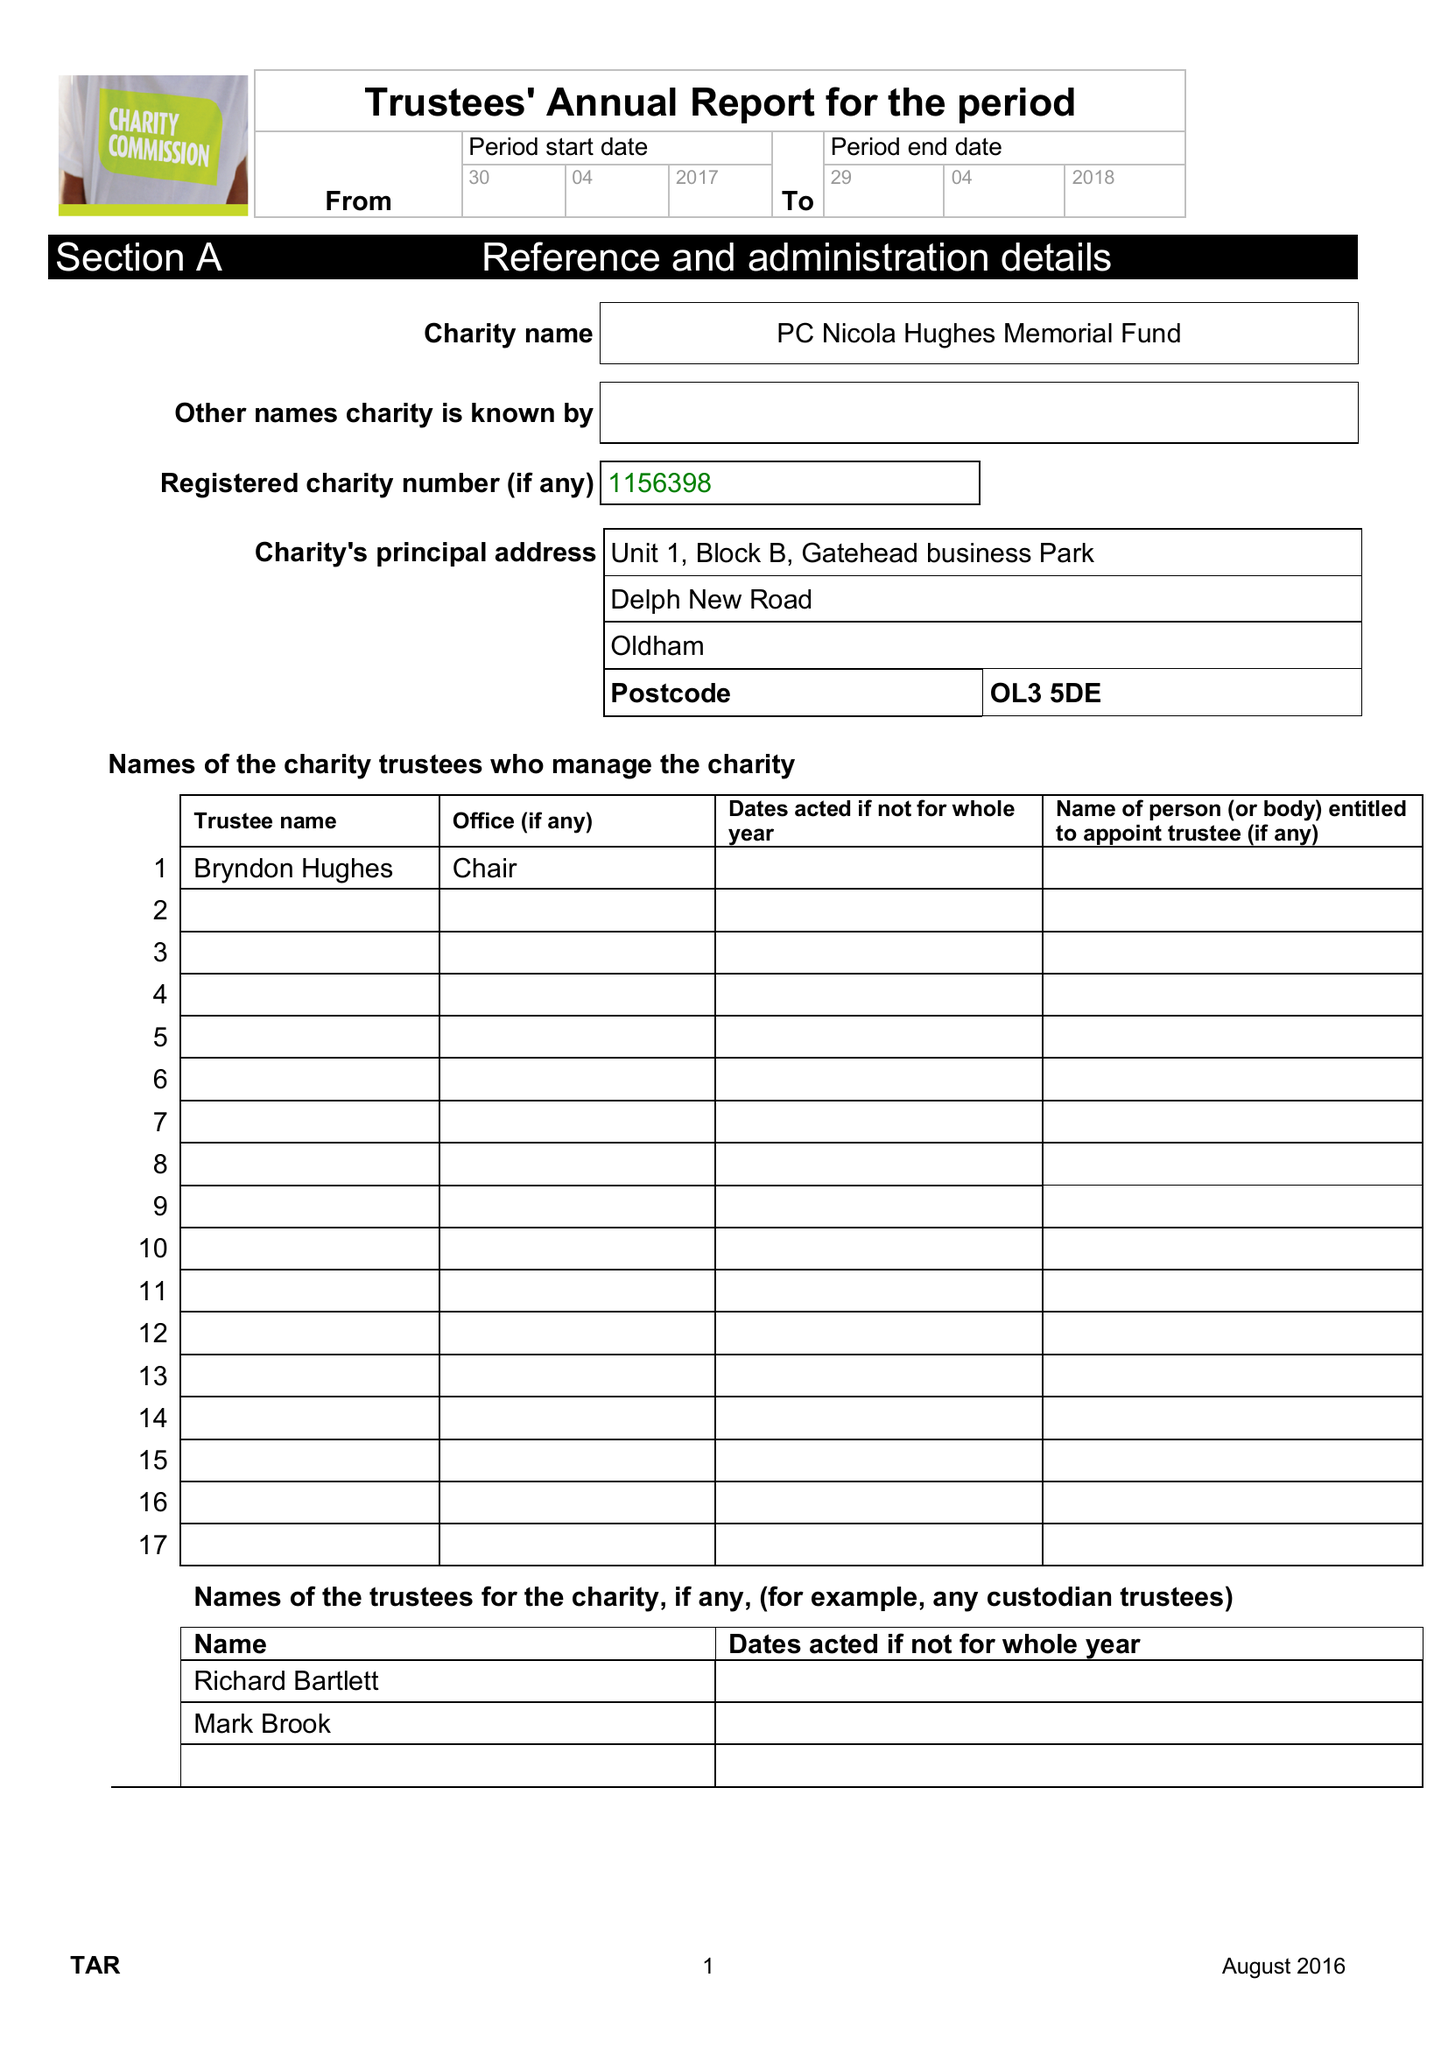What is the value for the address__postcode?
Answer the question using a single word or phrase. OL3 5DE 